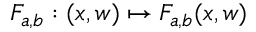Convert formula to latex. <formula><loc_0><loc_0><loc_500><loc_500>F _ { a , b } \colon ( x , w ) \mapsto F _ { a , b } ( x , w )</formula> 